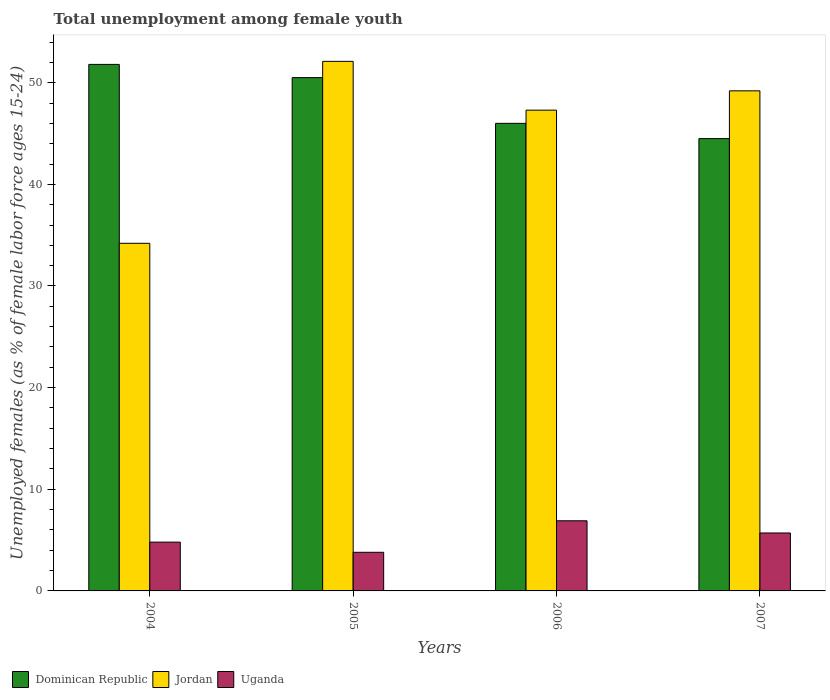How many different coloured bars are there?
Offer a very short reply. 3. How many groups of bars are there?
Your response must be concise. 4. Are the number of bars per tick equal to the number of legend labels?
Your answer should be very brief. Yes. How many bars are there on the 1st tick from the left?
Offer a very short reply. 3. What is the label of the 1st group of bars from the left?
Your answer should be very brief. 2004. In how many cases, is the number of bars for a given year not equal to the number of legend labels?
Provide a succinct answer. 0. What is the percentage of unemployed females in in Jordan in 2007?
Provide a succinct answer. 49.2. Across all years, what is the maximum percentage of unemployed females in in Jordan?
Offer a terse response. 52.1. Across all years, what is the minimum percentage of unemployed females in in Dominican Republic?
Your answer should be very brief. 44.5. In which year was the percentage of unemployed females in in Jordan maximum?
Provide a short and direct response. 2005. In which year was the percentage of unemployed females in in Dominican Republic minimum?
Your answer should be very brief. 2007. What is the total percentage of unemployed females in in Jordan in the graph?
Ensure brevity in your answer.  182.8. What is the difference between the percentage of unemployed females in in Dominican Republic in 2004 and that in 2007?
Offer a very short reply. 7.3. What is the difference between the percentage of unemployed females in in Uganda in 2005 and the percentage of unemployed females in in Jordan in 2006?
Your response must be concise. -43.5. What is the average percentage of unemployed females in in Dominican Republic per year?
Your answer should be compact. 48.2. In the year 2005, what is the difference between the percentage of unemployed females in in Dominican Republic and percentage of unemployed females in in Jordan?
Give a very brief answer. -1.6. What is the ratio of the percentage of unemployed females in in Jordan in 2004 to that in 2007?
Offer a terse response. 0.7. What is the difference between the highest and the second highest percentage of unemployed females in in Uganda?
Provide a succinct answer. 1.2. What is the difference between the highest and the lowest percentage of unemployed females in in Jordan?
Your answer should be compact. 17.9. In how many years, is the percentage of unemployed females in in Dominican Republic greater than the average percentage of unemployed females in in Dominican Republic taken over all years?
Your response must be concise. 2. What does the 2nd bar from the left in 2004 represents?
Provide a short and direct response. Jordan. What does the 2nd bar from the right in 2004 represents?
Provide a succinct answer. Jordan. Is it the case that in every year, the sum of the percentage of unemployed females in in Dominican Republic and percentage of unemployed females in in Uganda is greater than the percentage of unemployed females in in Jordan?
Your response must be concise. Yes. How many years are there in the graph?
Offer a very short reply. 4. Are the values on the major ticks of Y-axis written in scientific E-notation?
Ensure brevity in your answer.  No. Does the graph contain grids?
Your response must be concise. No. What is the title of the graph?
Provide a succinct answer. Total unemployment among female youth. Does "Grenada" appear as one of the legend labels in the graph?
Ensure brevity in your answer.  No. What is the label or title of the X-axis?
Make the answer very short. Years. What is the label or title of the Y-axis?
Ensure brevity in your answer.  Unemployed females (as % of female labor force ages 15-24). What is the Unemployed females (as % of female labor force ages 15-24) of Dominican Republic in 2004?
Your response must be concise. 51.8. What is the Unemployed females (as % of female labor force ages 15-24) in Jordan in 2004?
Ensure brevity in your answer.  34.2. What is the Unemployed females (as % of female labor force ages 15-24) of Uganda in 2004?
Ensure brevity in your answer.  4.8. What is the Unemployed females (as % of female labor force ages 15-24) of Dominican Republic in 2005?
Make the answer very short. 50.5. What is the Unemployed females (as % of female labor force ages 15-24) of Jordan in 2005?
Ensure brevity in your answer.  52.1. What is the Unemployed females (as % of female labor force ages 15-24) of Uganda in 2005?
Ensure brevity in your answer.  3.8. What is the Unemployed females (as % of female labor force ages 15-24) in Jordan in 2006?
Provide a short and direct response. 47.3. What is the Unemployed females (as % of female labor force ages 15-24) in Uganda in 2006?
Your answer should be very brief. 6.9. What is the Unemployed females (as % of female labor force ages 15-24) in Dominican Republic in 2007?
Offer a terse response. 44.5. What is the Unemployed females (as % of female labor force ages 15-24) of Jordan in 2007?
Give a very brief answer. 49.2. What is the Unemployed females (as % of female labor force ages 15-24) in Uganda in 2007?
Ensure brevity in your answer.  5.7. Across all years, what is the maximum Unemployed females (as % of female labor force ages 15-24) in Dominican Republic?
Provide a short and direct response. 51.8. Across all years, what is the maximum Unemployed females (as % of female labor force ages 15-24) in Jordan?
Provide a short and direct response. 52.1. Across all years, what is the maximum Unemployed females (as % of female labor force ages 15-24) of Uganda?
Your answer should be very brief. 6.9. Across all years, what is the minimum Unemployed females (as % of female labor force ages 15-24) of Dominican Republic?
Your answer should be compact. 44.5. Across all years, what is the minimum Unemployed females (as % of female labor force ages 15-24) of Jordan?
Ensure brevity in your answer.  34.2. Across all years, what is the minimum Unemployed females (as % of female labor force ages 15-24) of Uganda?
Your answer should be very brief. 3.8. What is the total Unemployed females (as % of female labor force ages 15-24) in Dominican Republic in the graph?
Provide a succinct answer. 192.8. What is the total Unemployed females (as % of female labor force ages 15-24) of Jordan in the graph?
Provide a short and direct response. 182.8. What is the total Unemployed females (as % of female labor force ages 15-24) of Uganda in the graph?
Make the answer very short. 21.2. What is the difference between the Unemployed females (as % of female labor force ages 15-24) in Jordan in 2004 and that in 2005?
Keep it short and to the point. -17.9. What is the difference between the Unemployed females (as % of female labor force ages 15-24) in Uganda in 2004 and that in 2005?
Offer a terse response. 1. What is the difference between the Unemployed females (as % of female labor force ages 15-24) of Jordan in 2004 and that in 2006?
Your response must be concise. -13.1. What is the difference between the Unemployed females (as % of female labor force ages 15-24) in Uganda in 2004 and that in 2006?
Your answer should be compact. -2.1. What is the difference between the Unemployed females (as % of female labor force ages 15-24) of Dominican Republic in 2005 and that in 2006?
Your response must be concise. 4.5. What is the difference between the Unemployed females (as % of female labor force ages 15-24) of Jordan in 2005 and that in 2006?
Your response must be concise. 4.8. What is the difference between the Unemployed females (as % of female labor force ages 15-24) in Jordan in 2005 and that in 2007?
Ensure brevity in your answer.  2.9. What is the difference between the Unemployed females (as % of female labor force ages 15-24) of Uganda in 2005 and that in 2007?
Give a very brief answer. -1.9. What is the difference between the Unemployed females (as % of female labor force ages 15-24) of Dominican Republic in 2004 and the Unemployed females (as % of female labor force ages 15-24) of Jordan in 2005?
Give a very brief answer. -0.3. What is the difference between the Unemployed females (as % of female labor force ages 15-24) of Jordan in 2004 and the Unemployed females (as % of female labor force ages 15-24) of Uganda in 2005?
Your answer should be compact. 30.4. What is the difference between the Unemployed females (as % of female labor force ages 15-24) in Dominican Republic in 2004 and the Unemployed females (as % of female labor force ages 15-24) in Jordan in 2006?
Your response must be concise. 4.5. What is the difference between the Unemployed females (as % of female labor force ages 15-24) in Dominican Republic in 2004 and the Unemployed females (as % of female labor force ages 15-24) in Uganda in 2006?
Your response must be concise. 44.9. What is the difference between the Unemployed females (as % of female labor force ages 15-24) in Jordan in 2004 and the Unemployed females (as % of female labor force ages 15-24) in Uganda in 2006?
Your response must be concise. 27.3. What is the difference between the Unemployed females (as % of female labor force ages 15-24) of Dominican Republic in 2004 and the Unemployed females (as % of female labor force ages 15-24) of Uganda in 2007?
Ensure brevity in your answer.  46.1. What is the difference between the Unemployed females (as % of female labor force ages 15-24) of Jordan in 2004 and the Unemployed females (as % of female labor force ages 15-24) of Uganda in 2007?
Provide a short and direct response. 28.5. What is the difference between the Unemployed females (as % of female labor force ages 15-24) of Dominican Republic in 2005 and the Unemployed females (as % of female labor force ages 15-24) of Uganda in 2006?
Your response must be concise. 43.6. What is the difference between the Unemployed females (as % of female labor force ages 15-24) in Jordan in 2005 and the Unemployed females (as % of female labor force ages 15-24) in Uganda in 2006?
Your answer should be very brief. 45.2. What is the difference between the Unemployed females (as % of female labor force ages 15-24) in Dominican Republic in 2005 and the Unemployed females (as % of female labor force ages 15-24) in Uganda in 2007?
Your answer should be compact. 44.8. What is the difference between the Unemployed females (as % of female labor force ages 15-24) of Jordan in 2005 and the Unemployed females (as % of female labor force ages 15-24) of Uganda in 2007?
Ensure brevity in your answer.  46.4. What is the difference between the Unemployed females (as % of female labor force ages 15-24) of Dominican Republic in 2006 and the Unemployed females (as % of female labor force ages 15-24) of Jordan in 2007?
Provide a short and direct response. -3.2. What is the difference between the Unemployed females (as % of female labor force ages 15-24) of Dominican Republic in 2006 and the Unemployed females (as % of female labor force ages 15-24) of Uganda in 2007?
Your answer should be very brief. 40.3. What is the difference between the Unemployed females (as % of female labor force ages 15-24) in Jordan in 2006 and the Unemployed females (as % of female labor force ages 15-24) in Uganda in 2007?
Provide a short and direct response. 41.6. What is the average Unemployed females (as % of female labor force ages 15-24) in Dominican Republic per year?
Ensure brevity in your answer.  48.2. What is the average Unemployed females (as % of female labor force ages 15-24) of Jordan per year?
Give a very brief answer. 45.7. In the year 2004, what is the difference between the Unemployed females (as % of female labor force ages 15-24) of Dominican Republic and Unemployed females (as % of female labor force ages 15-24) of Jordan?
Provide a short and direct response. 17.6. In the year 2004, what is the difference between the Unemployed females (as % of female labor force ages 15-24) in Dominican Republic and Unemployed females (as % of female labor force ages 15-24) in Uganda?
Your response must be concise. 47. In the year 2004, what is the difference between the Unemployed females (as % of female labor force ages 15-24) of Jordan and Unemployed females (as % of female labor force ages 15-24) of Uganda?
Offer a very short reply. 29.4. In the year 2005, what is the difference between the Unemployed females (as % of female labor force ages 15-24) in Dominican Republic and Unemployed females (as % of female labor force ages 15-24) in Uganda?
Your answer should be very brief. 46.7. In the year 2005, what is the difference between the Unemployed females (as % of female labor force ages 15-24) in Jordan and Unemployed females (as % of female labor force ages 15-24) in Uganda?
Your answer should be compact. 48.3. In the year 2006, what is the difference between the Unemployed females (as % of female labor force ages 15-24) in Dominican Republic and Unemployed females (as % of female labor force ages 15-24) in Jordan?
Your answer should be compact. -1.3. In the year 2006, what is the difference between the Unemployed females (as % of female labor force ages 15-24) of Dominican Republic and Unemployed females (as % of female labor force ages 15-24) of Uganda?
Offer a very short reply. 39.1. In the year 2006, what is the difference between the Unemployed females (as % of female labor force ages 15-24) of Jordan and Unemployed females (as % of female labor force ages 15-24) of Uganda?
Your answer should be very brief. 40.4. In the year 2007, what is the difference between the Unemployed females (as % of female labor force ages 15-24) in Dominican Republic and Unemployed females (as % of female labor force ages 15-24) in Uganda?
Give a very brief answer. 38.8. In the year 2007, what is the difference between the Unemployed females (as % of female labor force ages 15-24) of Jordan and Unemployed females (as % of female labor force ages 15-24) of Uganda?
Make the answer very short. 43.5. What is the ratio of the Unemployed females (as % of female labor force ages 15-24) in Dominican Republic in 2004 to that in 2005?
Offer a terse response. 1.03. What is the ratio of the Unemployed females (as % of female labor force ages 15-24) in Jordan in 2004 to that in 2005?
Offer a terse response. 0.66. What is the ratio of the Unemployed females (as % of female labor force ages 15-24) in Uganda in 2004 to that in 2005?
Make the answer very short. 1.26. What is the ratio of the Unemployed females (as % of female labor force ages 15-24) of Dominican Republic in 2004 to that in 2006?
Your response must be concise. 1.13. What is the ratio of the Unemployed females (as % of female labor force ages 15-24) in Jordan in 2004 to that in 2006?
Keep it short and to the point. 0.72. What is the ratio of the Unemployed females (as % of female labor force ages 15-24) of Uganda in 2004 to that in 2006?
Ensure brevity in your answer.  0.7. What is the ratio of the Unemployed females (as % of female labor force ages 15-24) in Dominican Republic in 2004 to that in 2007?
Your answer should be very brief. 1.16. What is the ratio of the Unemployed females (as % of female labor force ages 15-24) in Jordan in 2004 to that in 2007?
Provide a succinct answer. 0.7. What is the ratio of the Unemployed females (as % of female labor force ages 15-24) in Uganda in 2004 to that in 2007?
Make the answer very short. 0.84. What is the ratio of the Unemployed females (as % of female labor force ages 15-24) in Dominican Republic in 2005 to that in 2006?
Ensure brevity in your answer.  1.1. What is the ratio of the Unemployed females (as % of female labor force ages 15-24) of Jordan in 2005 to that in 2006?
Your answer should be very brief. 1.1. What is the ratio of the Unemployed females (as % of female labor force ages 15-24) in Uganda in 2005 to that in 2006?
Keep it short and to the point. 0.55. What is the ratio of the Unemployed females (as % of female labor force ages 15-24) in Dominican Republic in 2005 to that in 2007?
Make the answer very short. 1.13. What is the ratio of the Unemployed females (as % of female labor force ages 15-24) in Jordan in 2005 to that in 2007?
Make the answer very short. 1.06. What is the ratio of the Unemployed females (as % of female labor force ages 15-24) in Dominican Republic in 2006 to that in 2007?
Provide a short and direct response. 1.03. What is the ratio of the Unemployed females (as % of female labor force ages 15-24) in Jordan in 2006 to that in 2007?
Make the answer very short. 0.96. What is the ratio of the Unemployed females (as % of female labor force ages 15-24) of Uganda in 2006 to that in 2007?
Your answer should be very brief. 1.21. What is the difference between the highest and the second highest Unemployed females (as % of female labor force ages 15-24) of Dominican Republic?
Provide a short and direct response. 1.3. What is the difference between the highest and the second highest Unemployed females (as % of female labor force ages 15-24) in Jordan?
Your response must be concise. 2.9. What is the difference between the highest and the lowest Unemployed females (as % of female labor force ages 15-24) in Dominican Republic?
Keep it short and to the point. 7.3. What is the difference between the highest and the lowest Unemployed females (as % of female labor force ages 15-24) of Jordan?
Your response must be concise. 17.9. What is the difference between the highest and the lowest Unemployed females (as % of female labor force ages 15-24) in Uganda?
Provide a succinct answer. 3.1. 